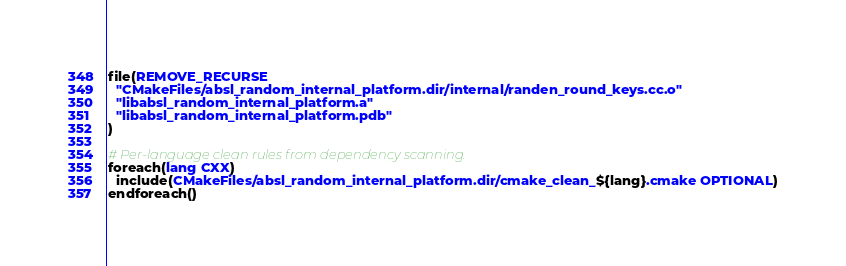<code> <loc_0><loc_0><loc_500><loc_500><_CMake_>file(REMOVE_RECURSE
  "CMakeFiles/absl_random_internal_platform.dir/internal/randen_round_keys.cc.o"
  "libabsl_random_internal_platform.a"
  "libabsl_random_internal_platform.pdb"
)

# Per-language clean rules from dependency scanning.
foreach(lang CXX)
  include(CMakeFiles/absl_random_internal_platform.dir/cmake_clean_${lang}.cmake OPTIONAL)
endforeach()
</code> 